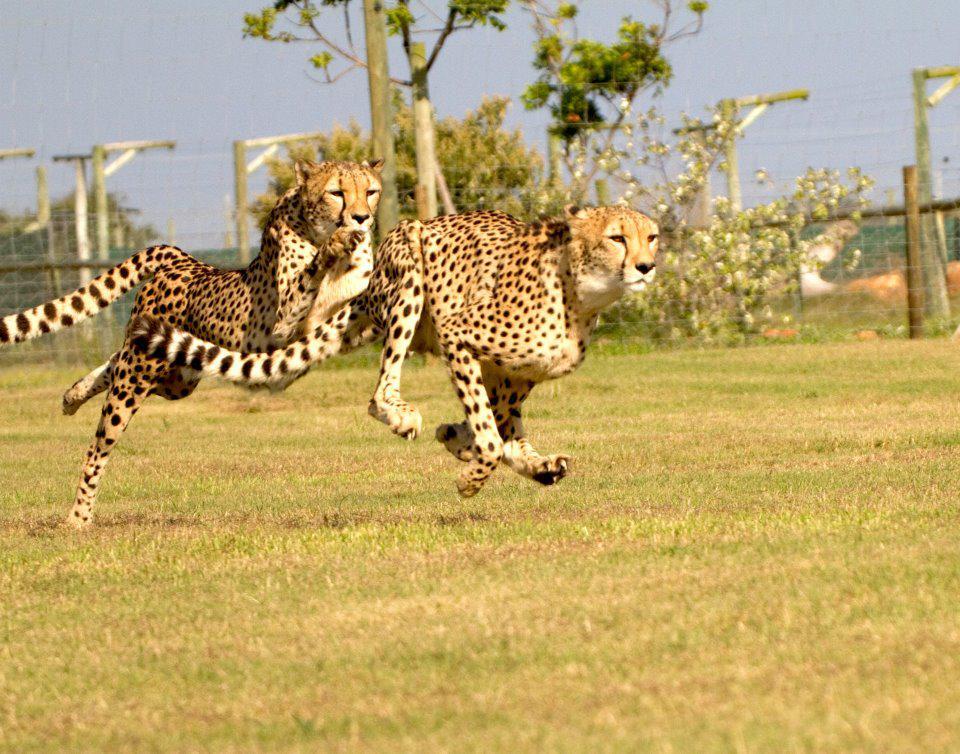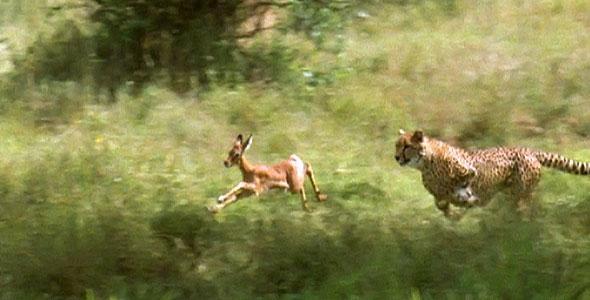The first image is the image on the left, the second image is the image on the right. Given the left and right images, does the statement "Two cheetahs are running." hold true? Answer yes or no. Yes. 